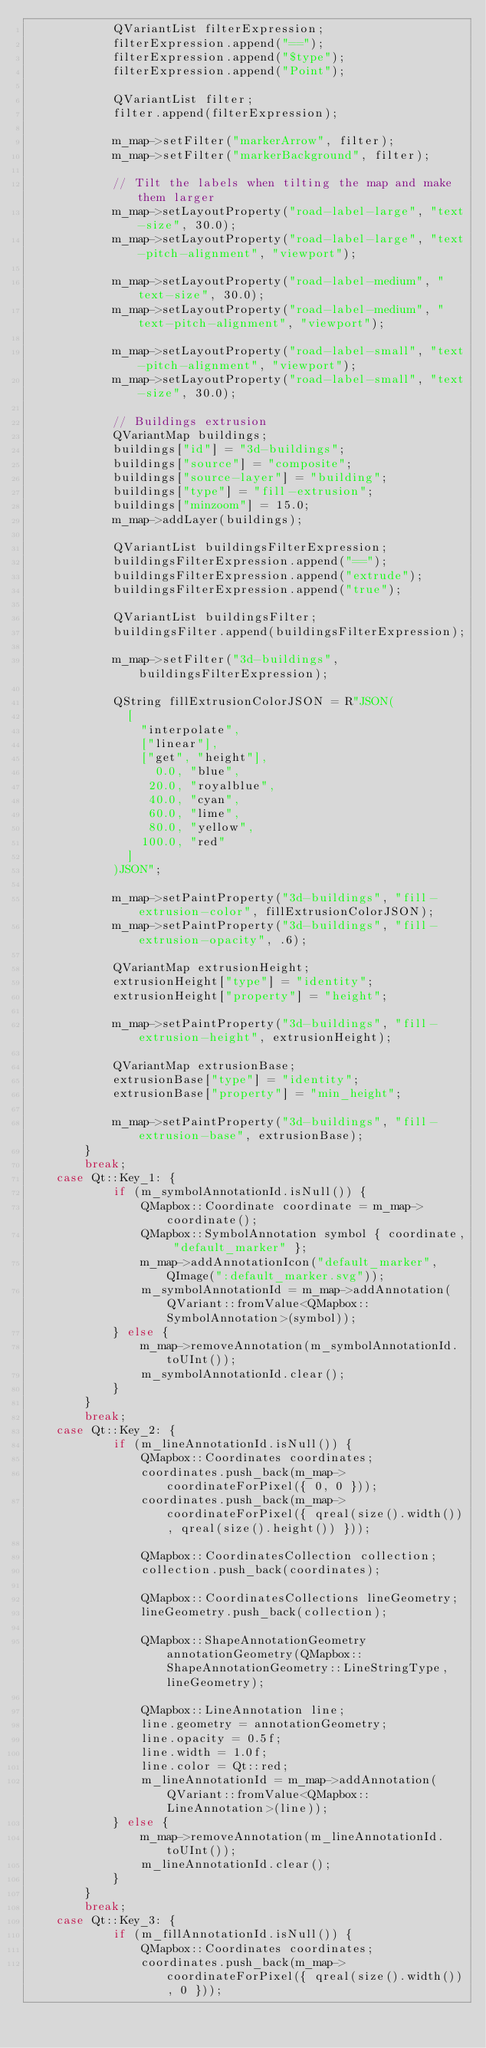Convert code to text. <code><loc_0><loc_0><loc_500><loc_500><_C++_>            QVariantList filterExpression;
            filterExpression.append("==");
            filterExpression.append("$type");
            filterExpression.append("Point");

            QVariantList filter;
            filter.append(filterExpression);

            m_map->setFilter("markerArrow", filter);
            m_map->setFilter("markerBackground", filter);

            // Tilt the labels when tilting the map and make them larger
            m_map->setLayoutProperty("road-label-large", "text-size", 30.0);
            m_map->setLayoutProperty("road-label-large", "text-pitch-alignment", "viewport");

            m_map->setLayoutProperty("road-label-medium", "text-size", 30.0);
            m_map->setLayoutProperty("road-label-medium", "text-pitch-alignment", "viewport");

            m_map->setLayoutProperty("road-label-small", "text-pitch-alignment", "viewport");
            m_map->setLayoutProperty("road-label-small", "text-size", 30.0);

            // Buildings extrusion
            QVariantMap buildings;
            buildings["id"] = "3d-buildings";
            buildings["source"] = "composite";
            buildings["source-layer"] = "building";
            buildings["type"] = "fill-extrusion";
            buildings["minzoom"] = 15.0;
            m_map->addLayer(buildings);

            QVariantList buildingsFilterExpression;
            buildingsFilterExpression.append("==");
            buildingsFilterExpression.append("extrude");
            buildingsFilterExpression.append("true");

            QVariantList buildingsFilter;
            buildingsFilter.append(buildingsFilterExpression);

            m_map->setFilter("3d-buildings", buildingsFilterExpression);

            QString fillExtrusionColorJSON = R"JSON(
              [
                "interpolate",
                ["linear"],
                ["get", "height"],
                  0.0, "blue",
                 20.0, "royalblue",
                 40.0, "cyan",
                 60.0, "lime",
                 80.0, "yellow",
                100.0, "red"
              ]
            )JSON";

            m_map->setPaintProperty("3d-buildings", "fill-extrusion-color", fillExtrusionColorJSON);
            m_map->setPaintProperty("3d-buildings", "fill-extrusion-opacity", .6);

            QVariantMap extrusionHeight;
            extrusionHeight["type"] = "identity";
            extrusionHeight["property"] = "height";

            m_map->setPaintProperty("3d-buildings", "fill-extrusion-height", extrusionHeight);

            QVariantMap extrusionBase;
            extrusionBase["type"] = "identity";
            extrusionBase["property"] = "min_height";

            m_map->setPaintProperty("3d-buildings", "fill-extrusion-base", extrusionBase);
        }
        break;
    case Qt::Key_1: {
            if (m_symbolAnnotationId.isNull()) {
                QMapbox::Coordinate coordinate = m_map->coordinate();
                QMapbox::SymbolAnnotation symbol { coordinate, "default_marker" };
                m_map->addAnnotationIcon("default_marker", QImage(":default_marker.svg"));
                m_symbolAnnotationId = m_map->addAnnotation(QVariant::fromValue<QMapbox::SymbolAnnotation>(symbol));
            } else {
                m_map->removeAnnotation(m_symbolAnnotationId.toUInt());
                m_symbolAnnotationId.clear();
            }
        }
        break;
    case Qt::Key_2: {
            if (m_lineAnnotationId.isNull()) {
                QMapbox::Coordinates coordinates;
                coordinates.push_back(m_map->coordinateForPixel({ 0, 0 }));
                coordinates.push_back(m_map->coordinateForPixel({ qreal(size().width()), qreal(size().height()) }));

                QMapbox::CoordinatesCollection collection;
                collection.push_back(coordinates);

                QMapbox::CoordinatesCollections lineGeometry;
                lineGeometry.push_back(collection);

                QMapbox::ShapeAnnotationGeometry annotationGeometry(QMapbox::ShapeAnnotationGeometry::LineStringType, lineGeometry);

                QMapbox::LineAnnotation line;
                line.geometry = annotationGeometry;
                line.opacity = 0.5f;
                line.width = 1.0f;
                line.color = Qt::red;
                m_lineAnnotationId = m_map->addAnnotation(QVariant::fromValue<QMapbox::LineAnnotation>(line));
            } else {
                m_map->removeAnnotation(m_lineAnnotationId.toUInt());
                m_lineAnnotationId.clear();
            }
        }
        break;
    case Qt::Key_3: {
            if (m_fillAnnotationId.isNull()) {
                QMapbox::Coordinates coordinates;
                coordinates.push_back(m_map->coordinateForPixel({ qreal(size().width()), 0 }));</code> 